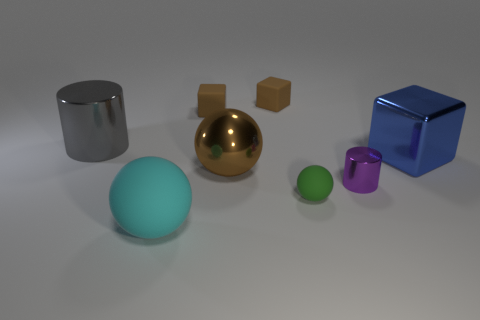What number of objects are tiny purple rubber cylinders or large metal objects that are to the right of the big gray cylinder?
Ensure brevity in your answer.  2. Are there any purple spheres that have the same material as the tiny cylinder?
Offer a terse response. No. There is a purple object that is the same size as the green rubber thing; what is it made of?
Your answer should be compact. Metal. What material is the brown cube that is on the left side of the big shiny thing in front of the large blue metallic object made of?
Offer a terse response. Rubber. Does the metallic thing that is on the left side of the cyan object have the same shape as the tiny purple object?
Provide a short and direct response. Yes. What is the color of the tiny cylinder that is the same material as the brown ball?
Offer a terse response. Purple. What material is the large object behind the large blue thing?
Your answer should be compact. Metal. Does the large blue shiny object have the same shape as the thing that is in front of the small matte ball?
Keep it short and to the point. No. What material is the big thing that is behind the shiny ball and to the left of the tiny shiny object?
Your answer should be compact. Metal. The cylinder that is the same size as the green thing is what color?
Make the answer very short. Purple. 